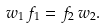Convert formula to latex. <formula><loc_0><loc_0><loc_500><loc_500>w _ { 1 } \, f _ { 1 } = f _ { 2 } \, w _ { 2 } .</formula> 